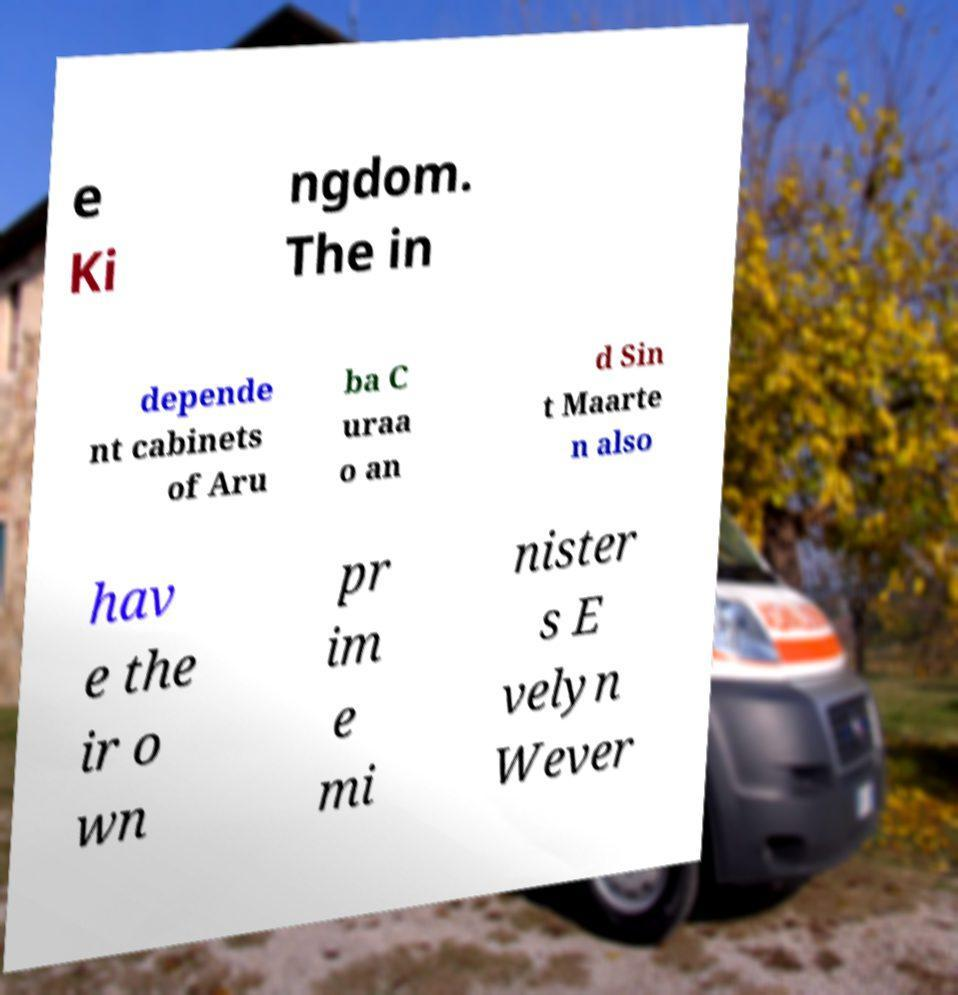Can you accurately transcribe the text from the provided image for me? e Ki ngdom. The in depende nt cabinets of Aru ba C uraa o an d Sin t Maarte n also hav e the ir o wn pr im e mi nister s E velyn Wever 